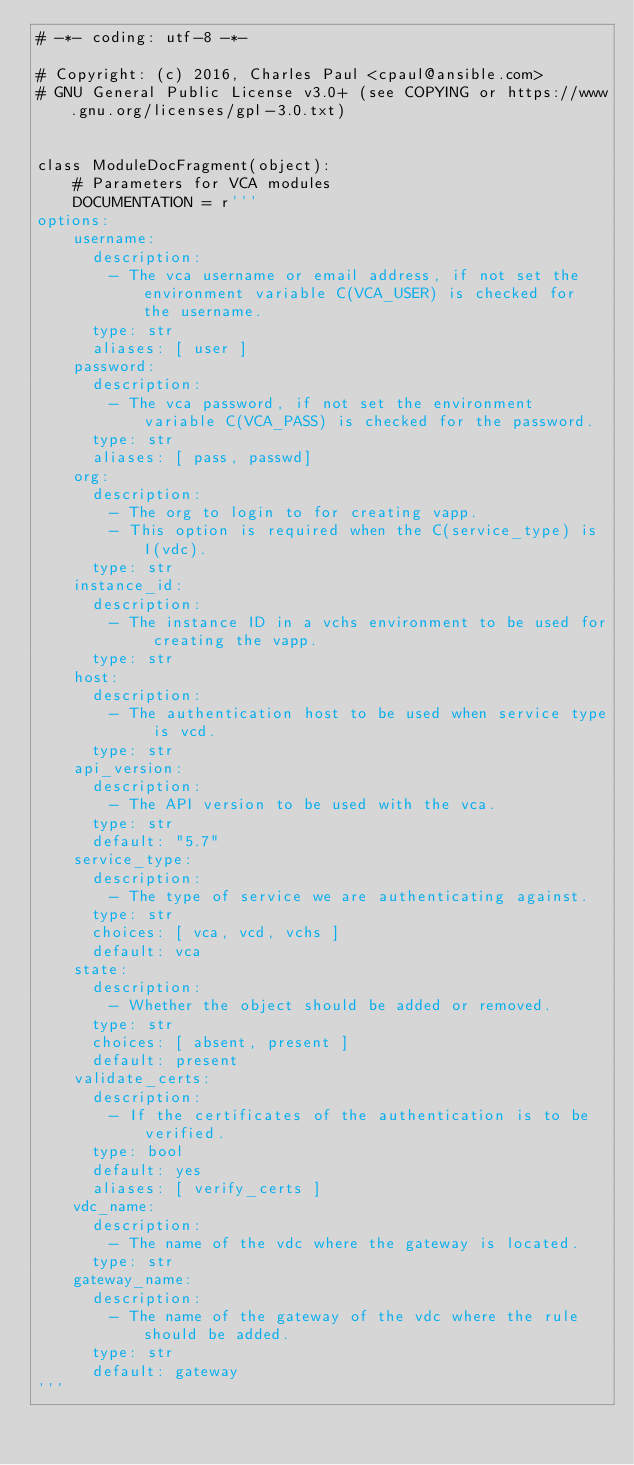<code> <loc_0><loc_0><loc_500><loc_500><_Python_># -*- coding: utf-8 -*-

# Copyright: (c) 2016, Charles Paul <cpaul@ansible.com>
# GNU General Public License v3.0+ (see COPYING or https://www.gnu.org/licenses/gpl-3.0.txt)


class ModuleDocFragment(object):
    # Parameters for VCA modules
    DOCUMENTATION = r'''
options:
    username:
      description:
        - The vca username or email address, if not set the environment variable C(VCA_USER) is checked for the username.
      type: str
      aliases: [ user ]
    password:
      description:
        - The vca password, if not set the environment variable C(VCA_PASS) is checked for the password.
      type: str
      aliases: [ pass, passwd]
    org:
      description:
        - The org to login to for creating vapp.
        - This option is required when the C(service_type) is I(vdc).
      type: str
    instance_id:
      description:
        - The instance ID in a vchs environment to be used for creating the vapp.
      type: str
    host:
      description:
        - The authentication host to be used when service type is vcd.
      type: str
    api_version:
      description:
        - The API version to be used with the vca.
      type: str
      default: "5.7"
    service_type:
      description:
        - The type of service we are authenticating against.
      type: str
      choices: [ vca, vcd, vchs ]
      default: vca
    state:
      description:
        - Whether the object should be added or removed.
      type: str
      choices: [ absent, present ]
      default: present
    validate_certs:
      description:
        - If the certificates of the authentication is to be verified.
      type: bool
      default: yes
      aliases: [ verify_certs ]
    vdc_name:
      description:
        - The name of the vdc where the gateway is located.
      type: str
    gateway_name:
      description:
        - The name of the gateway of the vdc where the rule should be added.
      type: str
      default: gateway
'''
</code> 